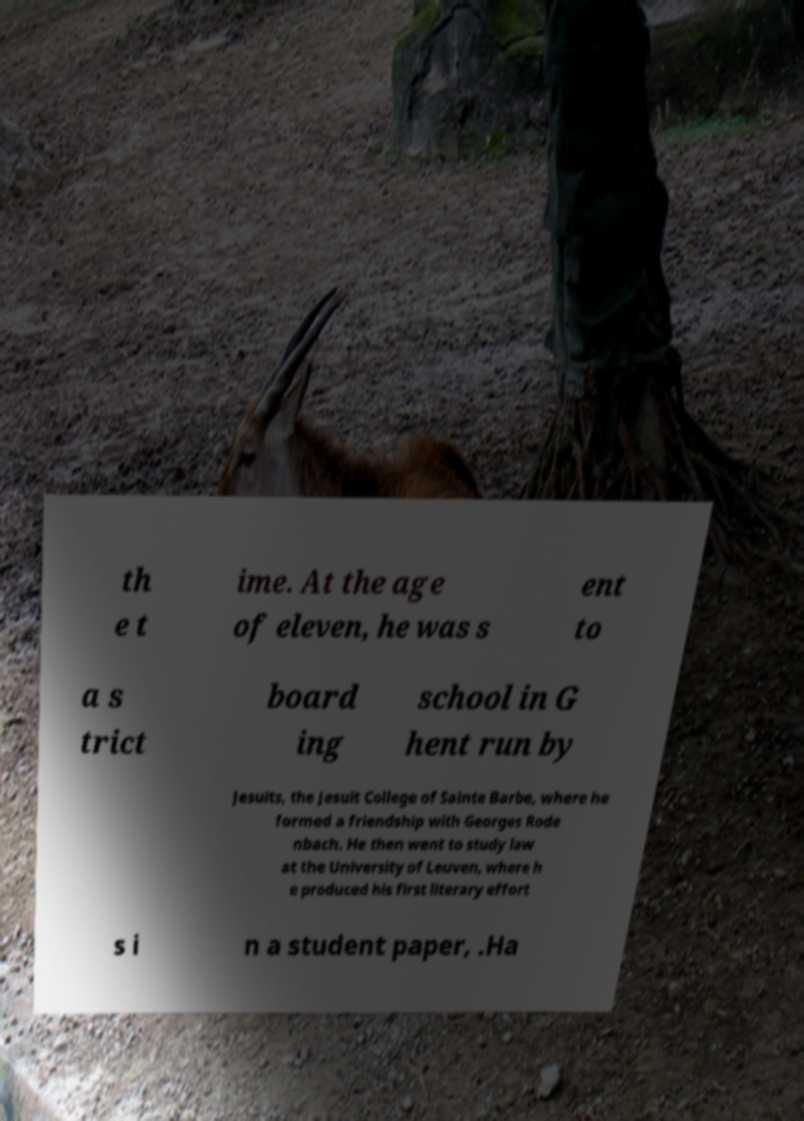Can you read and provide the text displayed in the image?This photo seems to have some interesting text. Can you extract and type it out for me? th e t ime. At the age of eleven, he was s ent to a s trict board ing school in G hent run by Jesuits, the Jesuit College of Sainte Barbe, where he formed a friendship with Georges Rode nbach. He then went to study law at the University of Leuven, where h e produced his first literary effort s i n a student paper, .Ha 